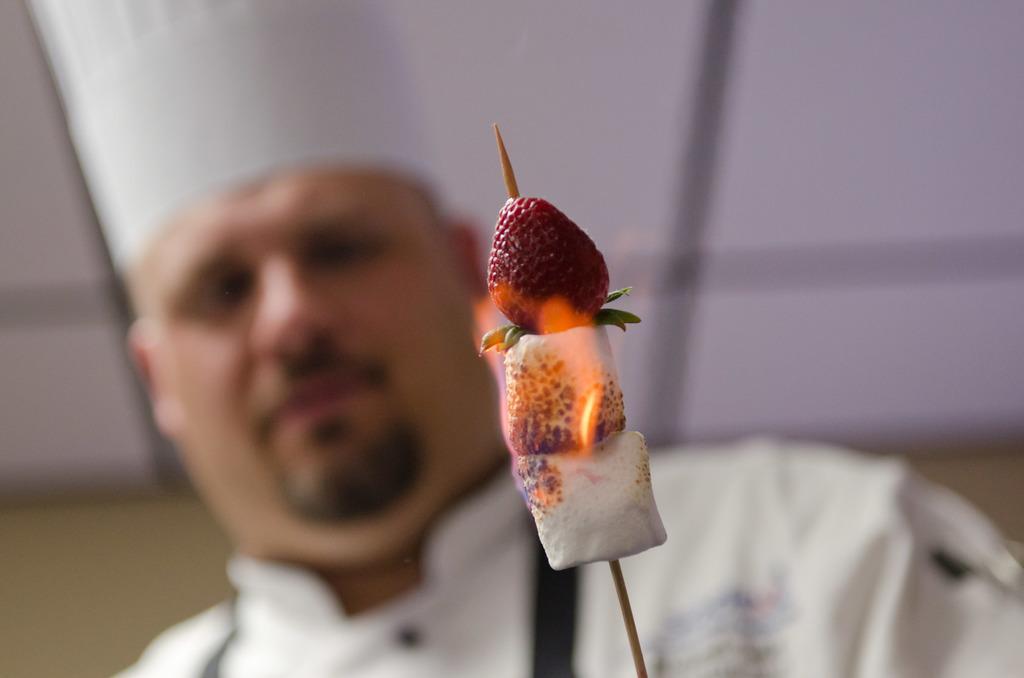Please provide a concise description of this image. There is a stick of strawberry in the foreground area of the image. There is a man in the background. 